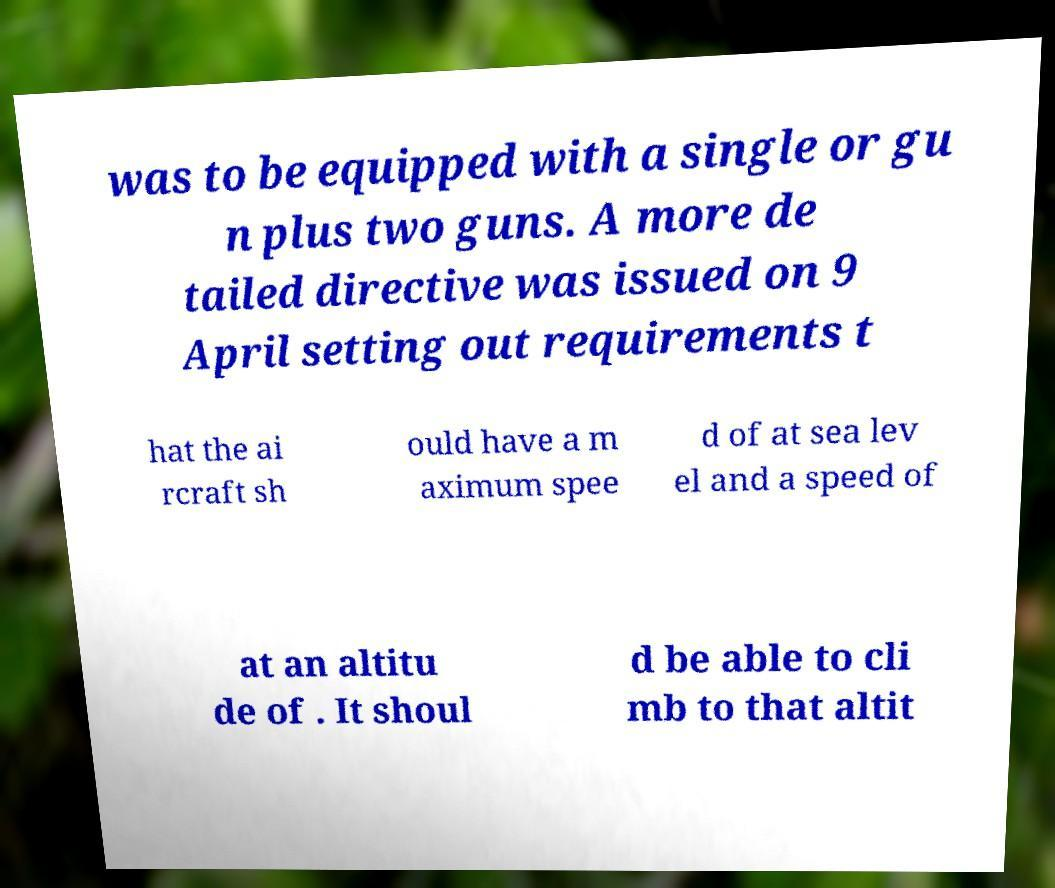I need the written content from this picture converted into text. Can you do that? was to be equipped with a single or gu n plus two guns. A more de tailed directive was issued on 9 April setting out requirements t hat the ai rcraft sh ould have a m aximum spee d of at sea lev el and a speed of at an altitu de of . It shoul d be able to cli mb to that altit 